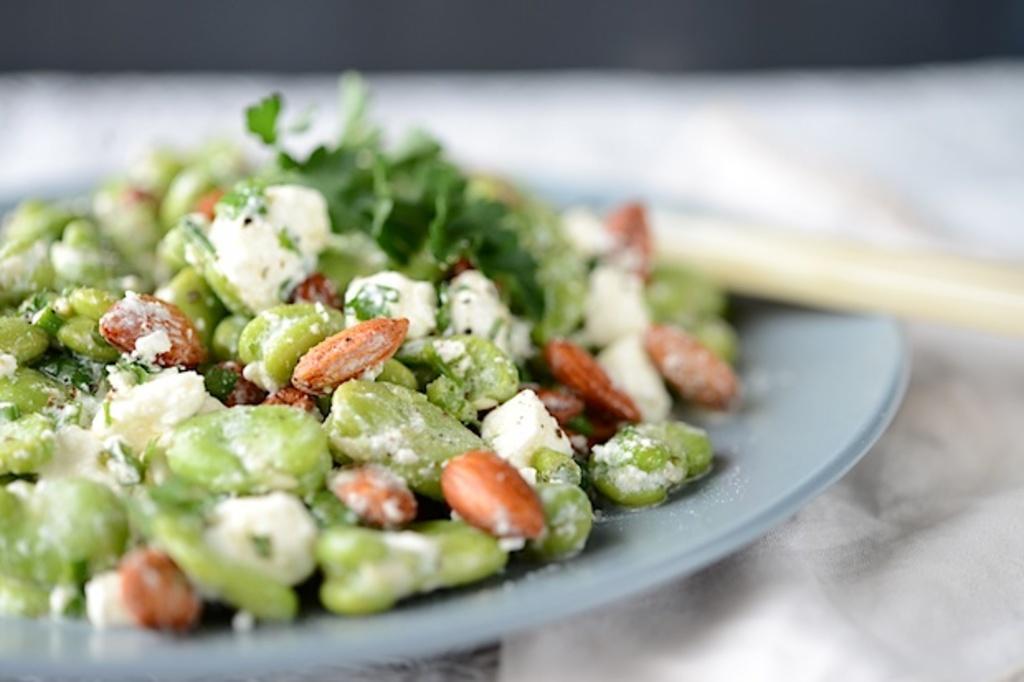Can you describe this image briefly? In this picture there are few eatables placed in a plate and there is a spoon in the right corner. 